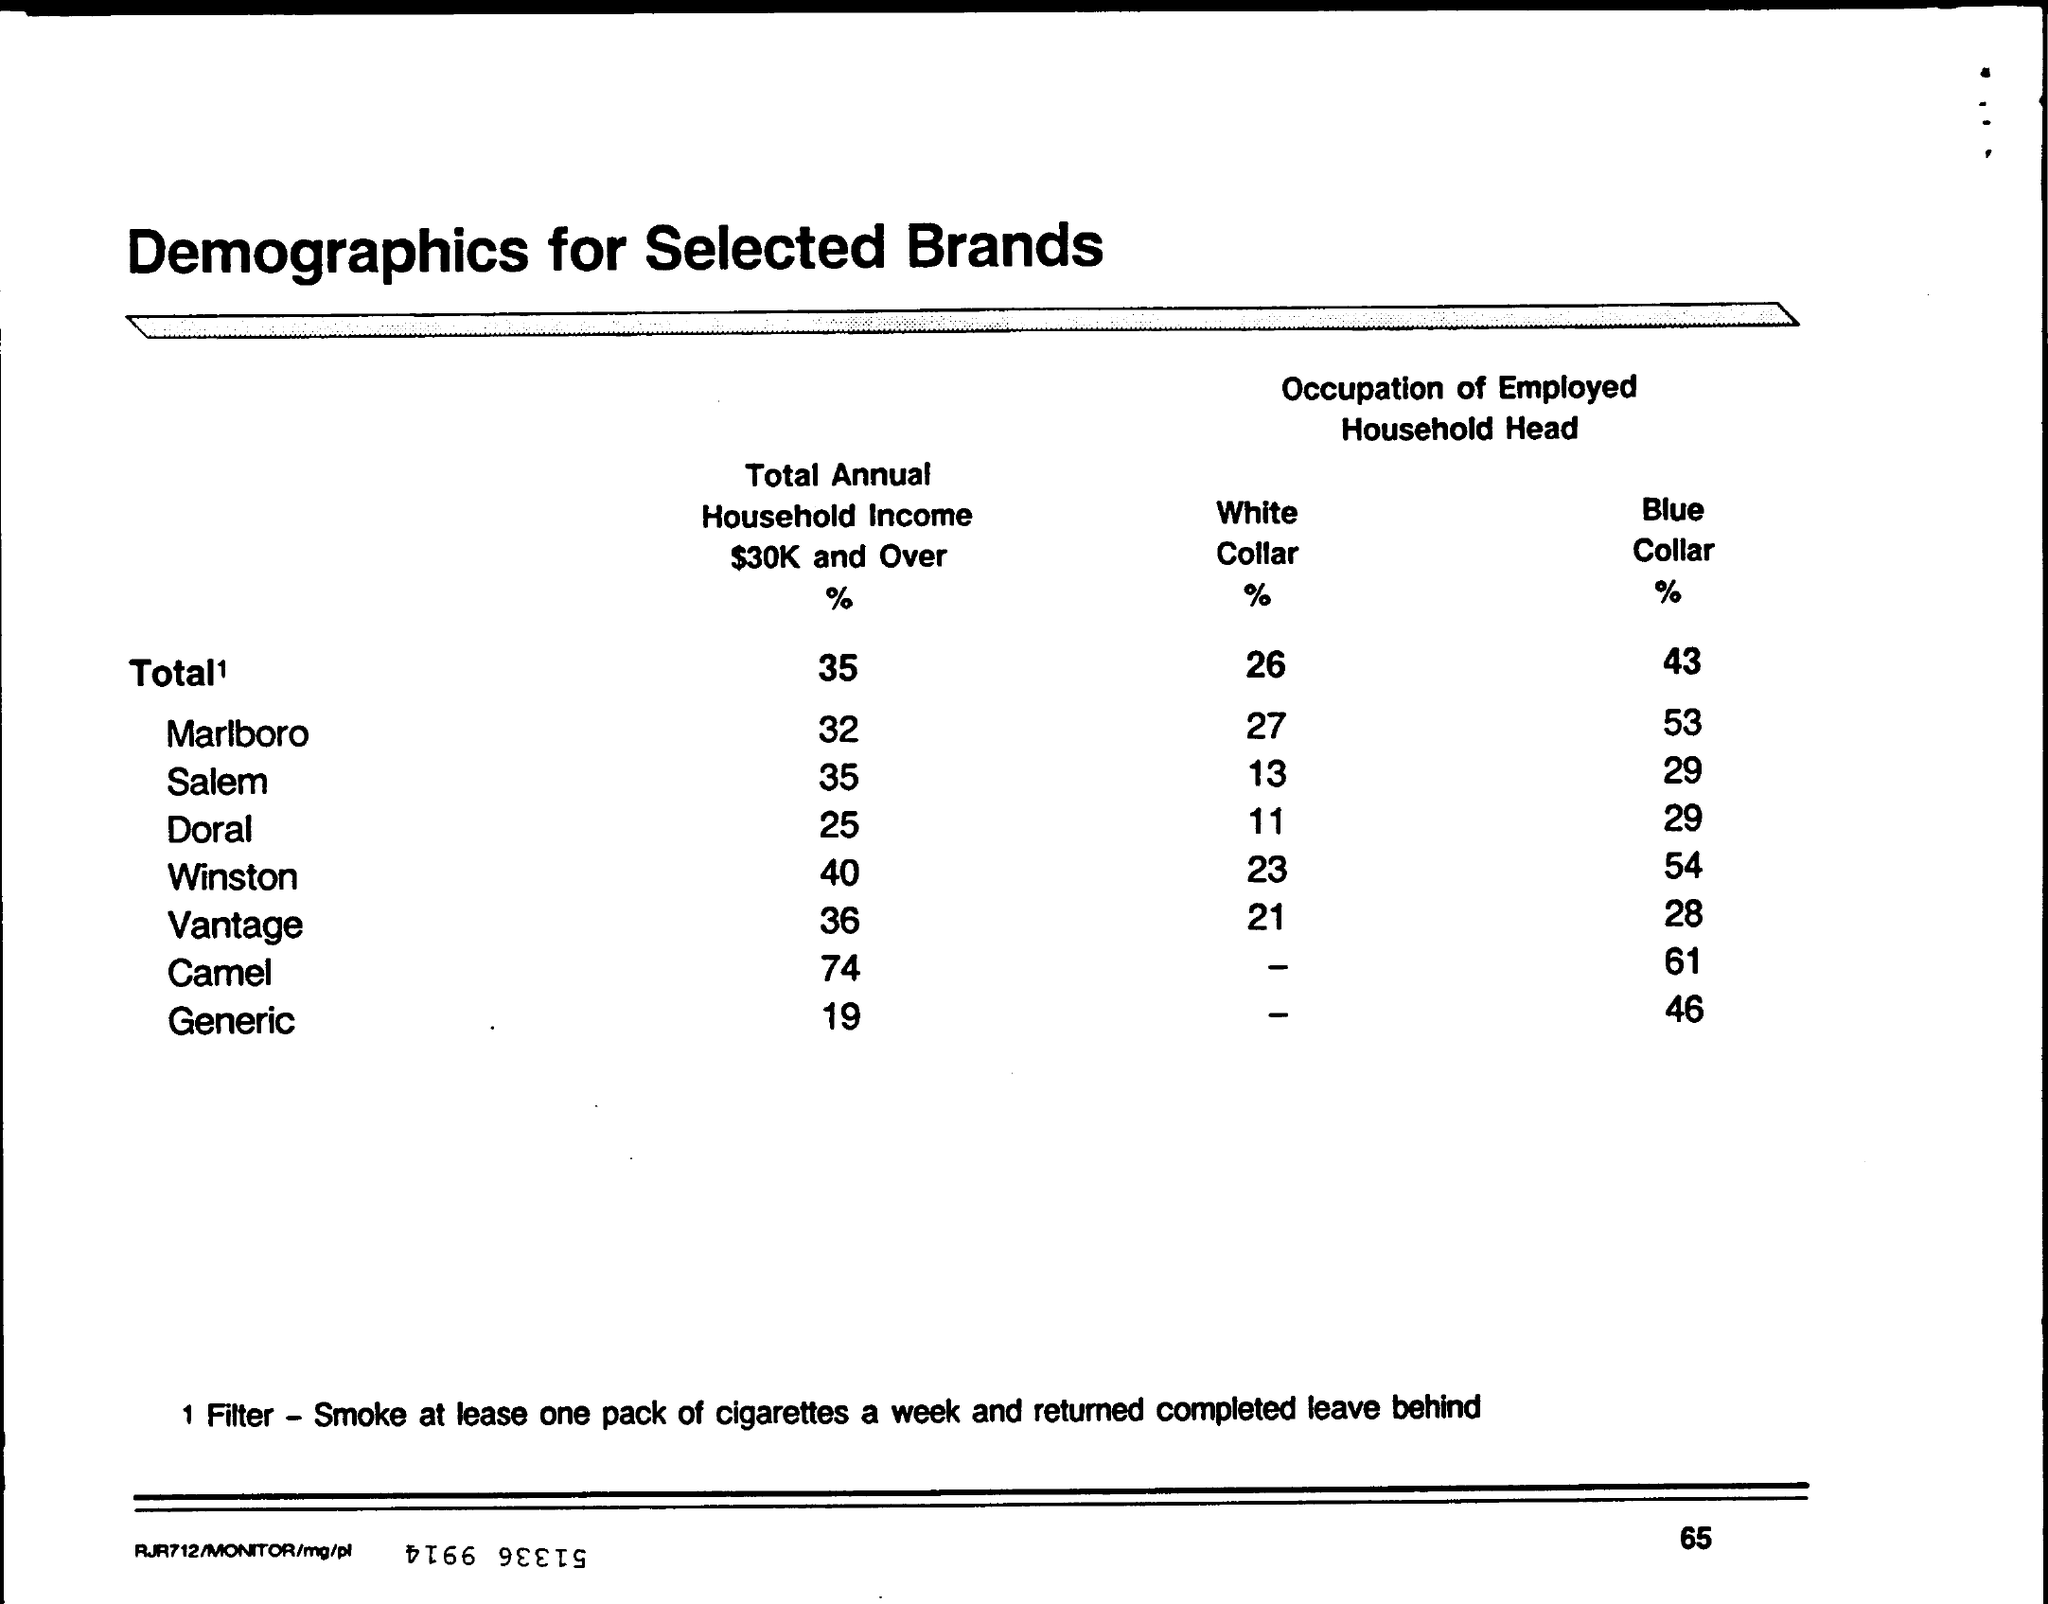Mention a couple of crucial points in this snapshot. The title of the table is 'Demographics for Selected Brands.' According to the data, 36% of individuals with a total annual household income of $30,000 or more used Vantage. 